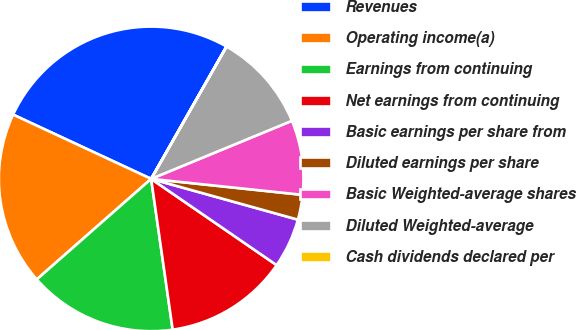Convert chart to OTSL. <chart><loc_0><loc_0><loc_500><loc_500><pie_chart><fcel>Revenues<fcel>Operating income(a)<fcel>Earnings from continuing<fcel>Net earnings from continuing<fcel>Basic earnings per share from<fcel>Diluted earnings per share<fcel>Basic Weighted-average shares<fcel>Diluted Weighted-average<fcel>Cash dividends declared per<nl><fcel>26.3%<fcel>18.41%<fcel>15.78%<fcel>13.16%<fcel>5.27%<fcel>2.64%<fcel>7.9%<fcel>10.53%<fcel>0.01%<nl></chart> 